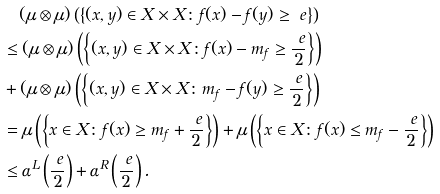<formula> <loc_0><loc_0><loc_500><loc_500>& \quad ( \mu \otimes \mu ) \left ( \left \{ ( x , y ) \in X \times X \colon f ( x ) - f ( y ) \geq \ e \right \} \right ) \\ & \leq ( \mu \otimes \mu ) \left ( \left \{ ( x , y ) \in X \times X \colon f ( x ) - m _ { f } \geq \frac { \ e } { 2 } \right \} \right ) \\ & + ( \mu \otimes \mu ) \left ( \left \{ ( x , y ) \in X \times X \colon m _ { f } - f ( y ) \geq \frac { \ e } { 2 } \right \} \right ) \\ & = \mu \left ( \left \{ x \in X \colon f ( x ) \geq m _ { f } + \frac { \ e } { 2 } \right \} \right ) + \mu \left ( \left \{ x \in X \colon f ( x ) \leq m _ { f } - \frac { \ e } { 2 } \right \} \right ) \\ & \leq \alpha ^ { L } \left ( \frac { \ e } { 2 } \right ) + \alpha ^ { R } \left ( \frac { \ e } { 2 } \right ) .</formula> 